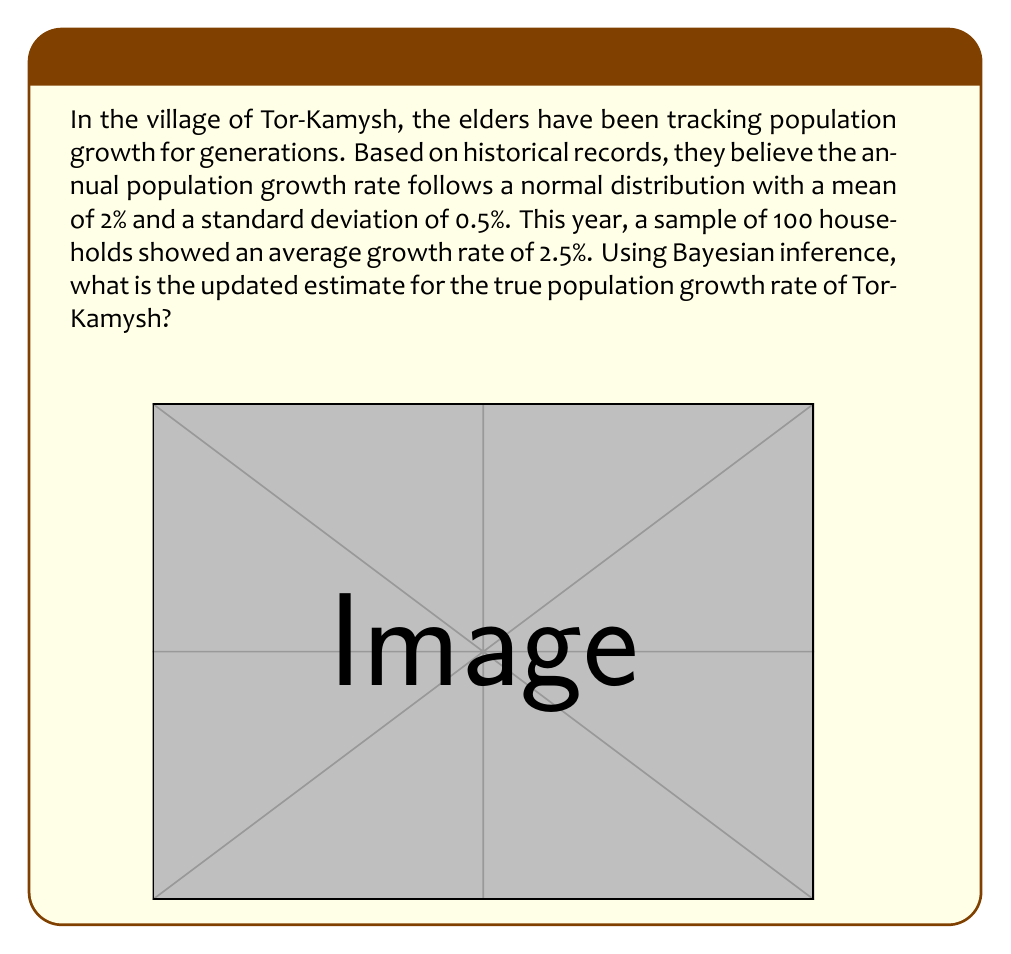Give your solution to this math problem. Let's approach this problem step-by-step using Bayesian inference:

1) Prior distribution:
   $\mu_0 = 2\%$, $\sigma_0 = 0.5\%$
   $\theta \sim N(2, 0.5^2)$

2) Likelihood:
   Sample size $n = 100$
   Sample mean $\bar{x} = 2.5\%$
   Standard error $SE = \frac{\sigma_0}{\sqrt{n}} = \frac{0.5}{\sqrt{100}} = 0.05$

3) Posterior distribution:
   We use the formula for updating a normal prior with normal likelihood:

   $\mu_1 = \frac{\frac{\mu_0}{\sigma_0^2} + \frac{n\bar{x}}{SE^2}}{\frac{1}{\sigma_0^2} + \frac{n}{SE^2}}$

   $\frac{1}{\sigma_1^2} = \frac{1}{\sigma_0^2} + \frac{n}{SE^2}$

4) Calculating posterior parameters:
   $\mu_1 = \frac{\frac{2}{0.5^2} + \frac{100 \cdot 2.5}{0.05^2}}{\frac{1}{0.5^2} + \frac{100}{0.05^2}} = \frac{8 + 10000}{4 + 40000} = \frac{10008}{40004} \approx 2.4992\%$

   $\frac{1}{\sigma_1^2} = \frac{1}{0.5^2} + \frac{100}{0.05^2} = 4 + 40000 = 40004$
   
   $\sigma_1 = \frac{1}{\sqrt{40004}} \approx 0.005\%$

5) Therefore, the updated estimate for the true population growth rate is approximately 2.4992% with a standard deviation of 0.005%.
Answer: $2.4992\%$ 